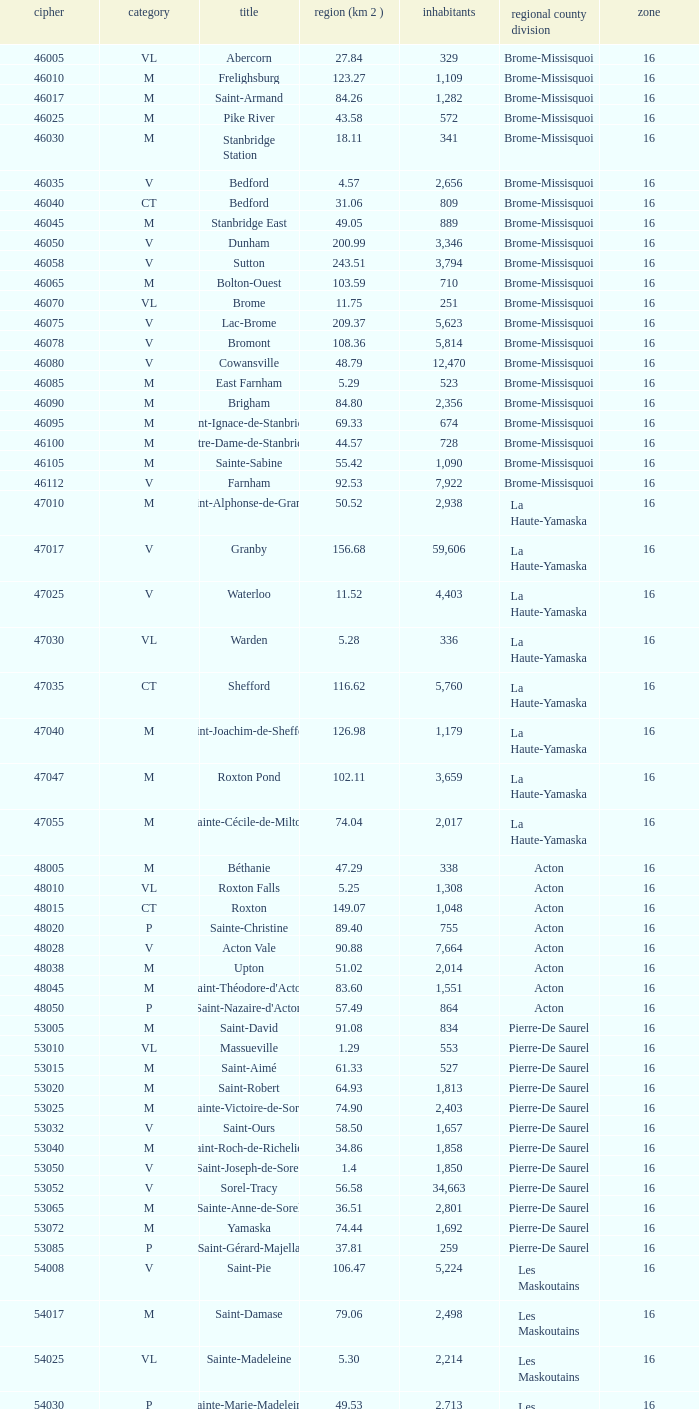Saint-Blaise-Sur-Richelieu is smaller than 68.42 km^2, what is the population of this type M municipality? None. 